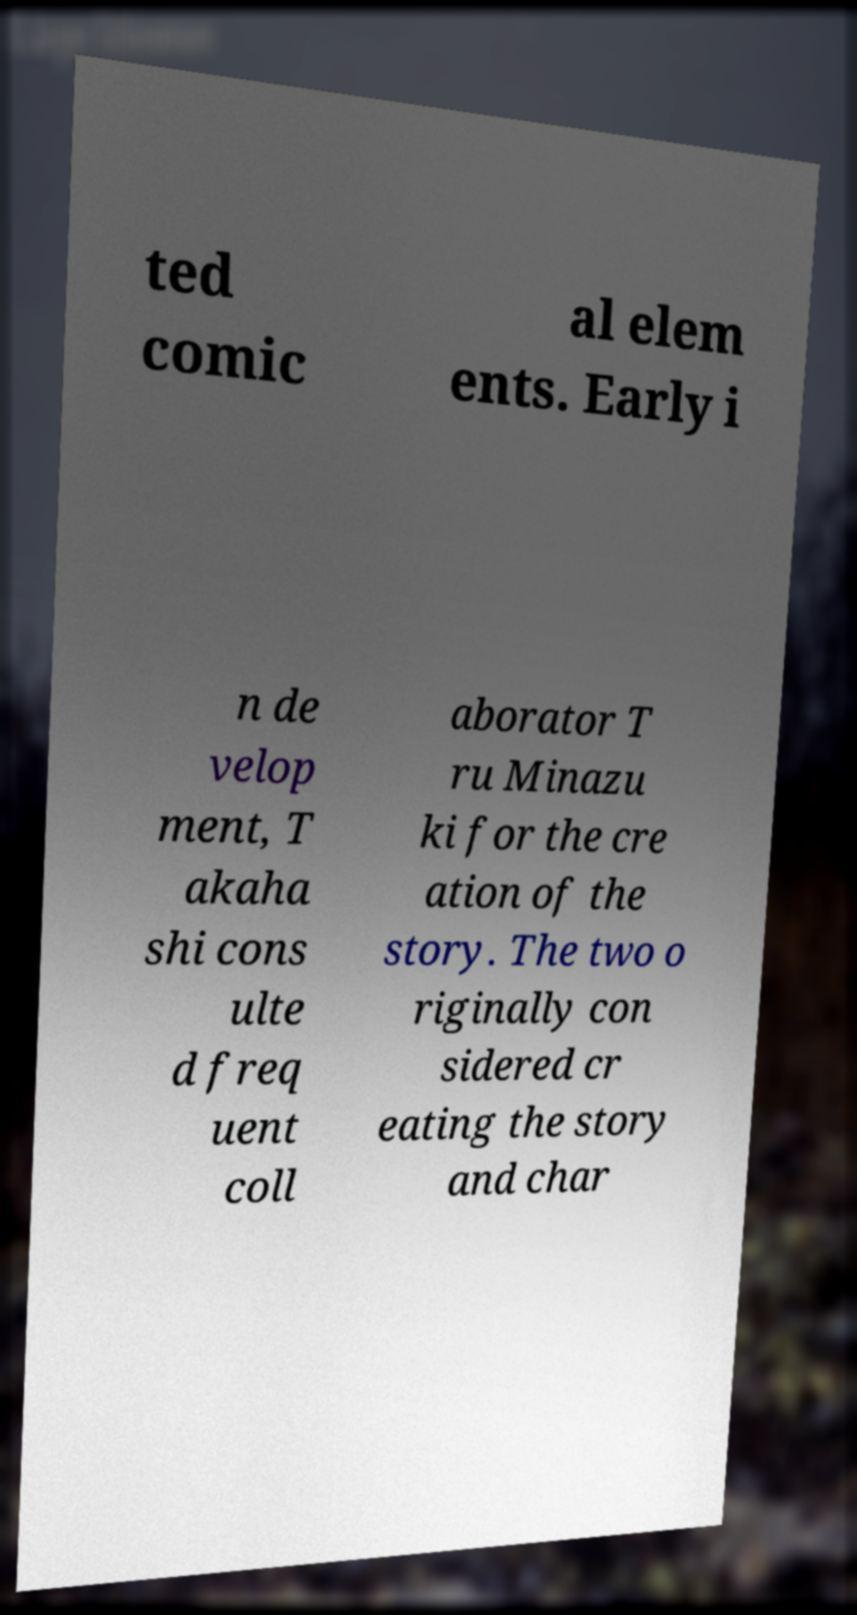Could you extract and type out the text from this image? ted comic al elem ents. Early i n de velop ment, T akaha shi cons ulte d freq uent coll aborator T ru Minazu ki for the cre ation of the story. The two o riginally con sidered cr eating the story and char 